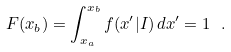Convert formula to latex. <formula><loc_0><loc_0><loc_500><loc_500>F ( x _ { b } ) = \int _ { x _ { a } } ^ { x _ { b } } f ( x ^ { \prime } | I ) \, d x ^ { \prime } = 1 \ .</formula> 